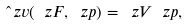<formula> <loc_0><loc_0><loc_500><loc_500>\hat { \ } z v ( \ z F , \ z p ) = \ z V \ z p ,</formula> 